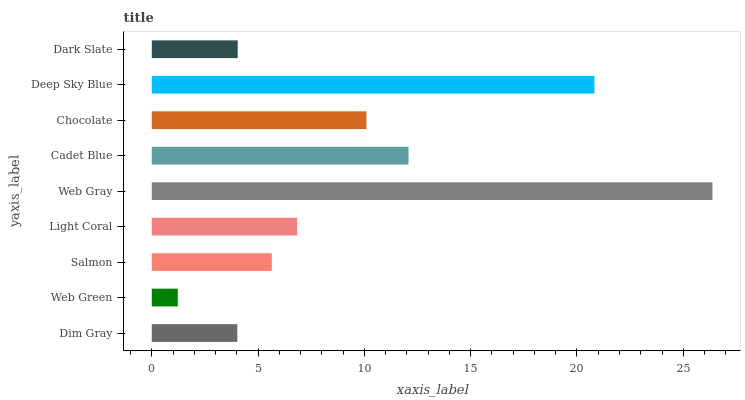Is Web Green the minimum?
Answer yes or no. Yes. Is Web Gray the maximum?
Answer yes or no. Yes. Is Salmon the minimum?
Answer yes or no. No. Is Salmon the maximum?
Answer yes or no. No. Is Salmon greater than Web Green?
Answer yes or no. Yes. Is Web Green less than Salmon?
Answer yes or no. Yes. Is Web Green greater than Salmon?
Answer yes or no. No. Is Salmon less than Web Green?
Answer yes or no. No. Is Light Coral the high median?
Answer yes or no. Yes. Is Light Coral the low median?
Answer yes or no. Yes. Is Chocolate the high median?
Answer yes or no. No. Is Web Gray the low median?
Answer yes or no. No. 